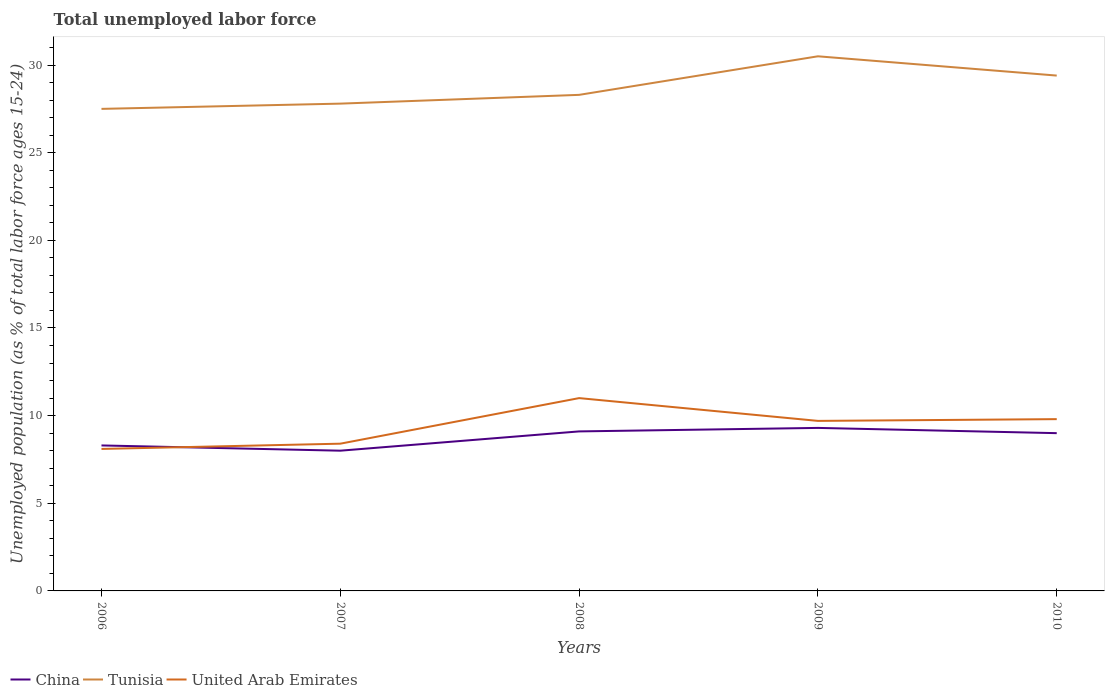Does the line corresponding to United Arab Emirates intersect with the line corresponding to Tunisia?
Make the answer very short. No. Across all years, what is the maximum percentage of unemployed population in in United Arab Emirates?
Offer a terse response. 8.1. What is the total percentage of unemployed population in in China in the graph?
Provide a succinct answer. -1. What is the difference between the highest and the second highest percentage of unemployed population in in United Arab Emirates?
Keep it short and to the point. 2.9. What is the difference between the highest and the lowest percentage of unemployed population in in China?
Your answer should be very brief. 3. How many years are there in the graph?
Offer a very short reply. 5. What is the difference between two consecutive major ticks on the Y-axis?
Give a very brief answer. 5. Are the values on the major ticks of Y-axis written in scientific E-notation?
Ensure brevity in your answer.  No. Does the graph contain any zero values?
Offer a terse response. No. Does the graph contain grids?
Make the answer very short. No. How many legend labels are there?
Give a very brief answer. 3. How are the legend labels stacked?
Give a very brief answer. Horizontal. What is the title of the graph?
Keep it short and to the point. Total unemployed labor force. Does "Swaziland" appear as one of the legend labels in the graph?
Your answer should be very brief. No. What is the label or title of the Y-axis?
Provide a short and direct response. Unemployed population (as % of total labor force ages 15-24). What is the Unemployed population (as % of total labor force ages 15-24) of China in 2006?
Ensure brevity in your answer.  8.3. What is the Unemployed population (as % of total labor force ages 15-24) in United Arab Emirates in 2006?
Provide a short and direct response. 8.1. What is the Unemployed population (as % of total labor force ages 15-24) in China in 2007?
Your response must be concise. 8. What is the Unemployed population (as % of total labor force ages 15-24) in Tunisia in 2007?
Your answer should be very brief. 27.8. What is the Unemployed population (as % of total labor force ages 15-24) in United Arab Emirates in 2007?
Your response must be concise. 8.4. What is the Unemployed population (as % of total labor force ages 15-24) in China in 2008?
Give a very brief answer. 9.1. What is the Unemployed population (as % of total labor force ages 15-24) in Tunisia in 2008?
Offer a very short reply. 28.3. What is the Unemployed population (as % of total labor force ages 15-24) in China in 2009?
Your answer should be compact. 9.3. What is the Unemployed population (as % of total labor force ages 15-24) of Tunisia in 2009?
Give a very brief answer. 30.5. What is the Unemployed population (as % of total labor force ages 15-24) of United Arab Emirates in 2009?
Offer a very short reply. 9.7. What is the Unemployed population (as % of total labor force ages 15-24) of Tunisia in 2010?
Offer a very short reply. 29.4. What is the Unemployed population (as % of total labor force ages 15-24) of United Arab Emirates in 2010?
Provide a short and direct response. 9.8. Across all years, what is the maximum Unemployed population (as % of total labor force ages 15-24) in China?
Your answer should be compact. 9.3. Across all years, what is the maximum Unemployed population (as % of total labor force ages 15-24) of Tunisia?
Provide a short and direct response. 30.5. Across all years, what is the maximum Unemployed population (as % of total labor force ages 15-24) in United Arab Emirates?
Provide a succinct answer. 11. Across all years, what is the minimum Unemployed population (as % of total labor force ages 15-24) in China?
Your answer should be very brief. 8. Across all years, what is the minimum Unemployed population (as % of total labor force ages 15-24) in Tunisia?
Offer a terse response. 27.5. Across all years, what is the minimum Unemployed population (as % of total labor force ages 15-24) of United Arab Emirates?
Offer a very short reply. 8.1. What is the total Unemployed population (as % of total labor force ages 15-24) of China in the graph?
Your answer should be compact. 43.7. What is the total Unemployed population (as % of total labor force ages 15-24) of Tunisia in the graph?
Your answer should be very brief. 143.5. What is the total Unemployed population (as % of total labor force ages 15-24) in United Arab Emirates in the graph?
Offer a very short reply. 47. What is the difference between the Unemployed population (as % of total labor force ages 15-24) of United Arab Emirates in 2006 and that in 2007?
Ensure brevity in your answer.  -0.3. What is the difference between the Unemployed population (as % of total labor force ages 15-24) of China in 2006 and that in 2008?
Make the answer very short. -0.8. What is the difference between the Unemployed population (as % of total labor force ages 15-24) in Tunisia in 2006 and that in 2008?
Give a very brief answer. -0.8. What is the difference between the Unemployed population (as % of total labor force ages 15-24) of China in 2006 and that in 2010?
Your response must be concise. -0.7. What is the difference between the Unemployed population (as % of total labor force ages 15-24) in Tunisia in 2006 and that in 2010?
Provide a short and direct response. -1.9. What is the difference between the Unemployed population (as % of total labor force ages 15-24) of Tunisia in 2007 and that in 2008?
Give a very brief answer. -0.5. What is the difference between the Unemployed population (as % of total labor force ages 15-24) in United Arab Emirates in 2007 and that in 2008?
Your answer should be very brief. -2.6. What is the difference between the Unemployed population (as % of total labor force ages 15-24) in Tunisia in 2007 and that in 2009?
Keep it short and to the point. -2.7. What is the difference between the Unemployed population (as % of total labor force ages 15-24) of China in 2007 and that in 2010?
Make the answer very short. -1. What is the difference between the Unemployed population (as % of total labor force ages 15-24) in United Arab Emirates in 2007 and that in 2010?
Give a very brief answer. -1.4. What is the difference between the Unemployed population (as % of total labor force ages 15-24) in United Arab Emirates in 2008 and that in 2009?
Your response must be concise. 1.3. What is the difference between the Unemployed population (as % of total labor force ages 15-24) of Tunisia in 2008 and that in 2010?
Offer a very short reply. -1.1. What is the difference between the Unemployed population (as % of total labor force ages 15-24) of United Arab Emirates in 2008 and that in 2010?
Your answer should be very brief. 1.2. What is the difference between the Unemployed population (as % of total labor force ages 15-24) in China in 2009 and that in 2010?
Offer a very short reply. 0.3. What is the difference between the Unemployed population (as % of total labor force ages 15-24) of Tunisia in 2009 and that in 2010?
Your answer should be compact. 1.1. What is the difference between the Unemployed population (as % of total labor force ages 15-24) in United Arab Emirates in 2009 and that in 2010?
Provide a short and direct response. -0.1. What is the difference between the Unemployed population (as % of total labor force ages 15-24) of China in 2006 and the Unemployed population (as % of total labor force ages 15-24) of Tunisia in 2007?
Give a very brief answer. -19.5. What is the difference between the Unemployed population (as % of total labor force ages 15-24) of China in 2006 and the Unemployed population (as % of total labor force ages 15-24) of United Arab Emirates in 2007?
Keep it short and to the point. -0.1. What is the difference between the Unemployed population (as % of total labor force ages 15-24) of China in 2006 and the Unemployed population (as % of total labor force ages 15-24) of Tunisia in 2008?
Your response must be concise. -20. What is the difference between the Unemployed population (as % of total labor force ages 15-24) of Tunisia in 2006 and the Unemployed population (as % of total labor force ages 15-24) of United Arab Emirates in 2008?
Your response must be concise. 16.5. What is the difference between the Unemployed population (as % of total labor force ages 15-24) in China in 2006 and the Unemployed population (as % of total labor force ages 15-24) in Tunisia in 2009?
Provide a succinct answer. -22.2. What is the difference between the Unemployed population (as % of total labor force ages 15-24) in Tunisia in 2006 and the Unemployed population (as % of total labor force ages 15-24) in United Arab Emirates in 2009?
Your answer should be compact. 17.8. What is the difference between the Unemployed population (as % of total labor force ages 15-24) of China in 2006 and the Unemployed population (as % of total labor force ages 15-24) of Tunisia in 2010?
Your response must be concise. -21.1. What is the difference between the Unemployed population (as % of total labor force ages 15-24) in China in 2006 and the Unemployed population (as % of total labor force ages 15-24) in United Arab Emirates in 2010?
Offer a very short reply. -1.5. What is the difference between the Unemployed population (as % of total labor force ages 15-24) in Tunisia in 2006 and the Unemployed population (as % of total labor force ages 15-24) in United Arab Emirates in 2010?
Provide a succinct answer. 17.7. What is the difference between the Unemployed population (as % of total labor force ages 15-24) of China in 2007 and the Unemployed population (as % of total labor force ages 15-24) of Tunisia in 2008?
Your answer should be very brief. -20.3. What is the difference between the Unemployed population (as % of total labor force ages 15-24) of China in 2007 and the Unemployed population (as % of total labor force ages 15-24) of Tunisia in 2009?
Provide a short and direct response. -22.5. What is the difference between the Unemployed population (as % of total labor force ages 15-24) of China in 2007 and the Unemployed population (as % of total labor force ages 15-24) of United Arab Emirates in 2009?
Ensure brevity in your answer.  -1.7. What is the difference between the Unemployed population (as % of total labor force ages 15-24) in China in 2007 and the Unemployed population (as % of total labor force ages 15-24) in Tunisia in 2010?
Your response must be concise. -21.4. What is the difference between the Unemployed population (as % of total labor force ages 15-24) in China in 2007 and the Unemployed population (as % of total labor force ages 15-24) in United Arab Emirates in 2010?
Provide a succinct answer. -1.8. What is the difference between the Unemployed population (as % of total labor force ages 15-24) in China in 2008 and the Unemployed population (as % of total labor force ages 15-24) in Tunisia in 2009?
Provide a succinct answer. -21.4. What is the difference between the Unemployed population (as % of total labor force ages 15-24) in China in 2008 and the Unemployed population (as % of total labor force ages 15-24) in Tunisia in 2010?
Offer a terse response. -20.3. What is the difference between the Unemployed population (as % of total labor force ages 15-24) in China in 2009 and the Unemployed population (as % of total labor force ages 15-24) in Tunisia in 2010?
Your response must be concise. -20.1. What is the difference between the Unemployed population (as % of total labor force ages 15-24) in China in 2009 and the Unemployed population (as % of total labor force ages 15-24) in United Arab Emirates in 2010?
Your response must be concise. -0.5. What is the difference between the Unemployed population (as % of total labor force ages 15-24) of Tunisia in 2009 and the Unemployed population (as % of total labor force ages 15-24) of United Arab Emirates in 2010?
Your response must be concise. 20.7. What is the average Unemployed population (as % of total labor force ages 15-24) in China per year?
Ensure brevity in your answer.  8.74. What is the average Unemployed population (as % of total labor force ages 15-24) in Tunisia per year?
Your answer should be compact. 28.7. In the year 2006, what is the difference between the Unemployed population (as % of total labor force ages 15-24) of China and Unemployed population (as % of total labor force ages 15-24) of Tunisia?
Provide a short and direct response. -19.2. In the year 2006, what is the difference between the Unemployed population (as % of total labor force ages 15-24) of Tunisia and Unemployed population (as % of total labor force ages 15-24) of United Arab Emirates?
Provide a short and direct response. 19.4. In the year 2007, what is the difference between the Unemployed population (as % of total labor force ages 15-24) in China and Unemployed population (as % of total labor force ages 15-24) in Tunisia?
Ensure brevity in your answer.  -19.8. In the year 2007, what is the difference between the Unemployed population (as % of total labor force ages 15-24) of China and Unemployed population (as % of total labor force ages 15-24) of United Arab Emirates?
Ensure brevity in your answer.  -0.4. In the year 2007, what is the difference between the Unemployed population (as % of total labor force ages 15-24) in Tunisia and Unemployed population (as % of total labor force ages 15-24) in United Arab Emirates?
Provide a short and direct response. 19.4. In the year 2008, what is the difference between the Unemployed population (as % of total labor force ages 15-24) of China and Unemployed population (as % of total labor force ages 15-24) of Tunisia?
Make the answer very short. -19.2. In the year 2009, what is the difference between the Unemployed population (as % of total labor force ages 15-24) in China and Unemployed population (as % of total labor force ages 15-24) in Tunisia?
Ensure brevity in your answer.  -21.2. In the year 2009, what is the difference between the Unemployed population (as % of total labor force ages 15-24) of China and Unemployed population (as % of total labor force ages 15-24) of United Arab Emirates?
Provide a succinct answer. -0.4. In the year 2009, what is the difference between the Unemployed population (as % of total labor force ages 15-24) in Tunisia and Unemployed population (as % of total labor force ages 15-24) in United Arab Emirates?
Keep it short and to the point. 20.8. In the year 2010, what is the difference between the Unemployed population (as % of total labor force ages 15-24) in China and Unemployed population (as % of total labor force ages 15-24) in Tunisia?
Provide a succinct answer. -20.4. In the year 2010, what is the difference between the Unemployed population (as % of total labor force ages 15-24) of China and Unemployed population (as % of total labor force ages 15-24) of United Arab Emirates?
Make the answer very short. -0.8. In the year 2010, what is the difference between the Unemployed population (as % of total labor force ages 15-24) of Tunisia and Unemployed population (as % of total labor force ages 15-24) of United Arab Emirates?
Your answer should be very brief. 19.6. What is the ratio of the Unemployed population (as % of total labor force ages 15-24) in China in 2006 to that in 2007?
Keep it short and to the point. 1.04. What is the ratio of the Unemployed population (as % of total labor force ages 15-24) of China in 2006 to that in 2008?
Offer a terse response. 0.91. What is the ratio of the Unemployed population (as % of total labor force ages 15-24) of Tunisia in 2006 to that in 2008?
Offer a terse response. 0.97. What is the ratio of the Unemployed population (as % of total labor force ages 15-24) of United Arab Emirates in 2006 to that in 2008?
Your answer should be very brief. 0.74. What is the ratio of the Unemployed population (as % of total labor force ages 15-24) in China in 2006 to that in 2009?
Give a very brief answer. 0.89. What is the ratio of the Unemployed population (as % of total labor force ages 15-24) of Tunisia in 2006 to that in 2009?
Offer a very short reply. 0.9. What is the ratio of the Unemployed population (as % of total labor force ages 15-24) in United Arab Emirates in 2006 to that in 2009?
Offer a terse response. 0.84. What is the ratio of the Unemployed population (as % of total labor force ages 15-24) in China in 2006 to that in 2010?
Offer a terse response. 0.92. What is the ratio of the Unemployed population (as % of total labor force ages 15-24) of Tunisia in 2006 to that in 2010?
Provide a succinct answer. 0.94. What is the ratio of the Unemployed population (as % of total labor force ages 15-24) in United Arab Emirates in 2006 to that in 2010?
Offer a terse response. 0.83. What is the ratio of the Unemployed population (as % of total labor force ages 15-24) of China in 2007 to that in 2008?
Your response must be concise. 0.88. What is the ratio of the Unemployed population (as % of total labor force ages 15-24) in Tunisia in 2007 to that in 2008?
Your response must be concise. 0.98. What is the ratio of the Unemployed population (as % of total labor force ages 15-24) in United Arab Emirates in 2007 to that in 2008?
Ensure brevity in your answer.  0.76. What is the ratio of the Unemployed population (as % of total labor force ages 15-24) of China in 2007 to that in 2009?
Your answer should be compact. 0.86. What is the ratio of the Unemployed population (as % of total labor force ages 15-24) of Tunisia in 2007 to that in 2009?
Give a very brief answer. 0.91. What is the ratio of the Unemployed population (as % of total labor force ages 15-24) of United Arab Emirates in 2007 to that in 2009?
Ensure brevity in your answer.  0.87. What is the ratio of the Unemployed population (as % of total labor force ages 15-24) in Tunisia in 2007 to that in 2010?
Give a very brief answer. 0.95. What is the ratio of the Unemployed population (as % of total labor force ages 15-24) of United Arab Emirates in 2007 to that in 2010?
Offer a terse response. 0.86. What is the ratio of the Unemployed population (as % of total labor force ages 15-24) of China in 2008 to that in 2009?
Provide a succinct answer. 0.98. What is the ratio of the Unemployed population (as % of total labor force ages 15-24) in Tunisia in 2008 to that in 2009?
Your answer should be very brief. 0.93. What is the ratio of the Unemployed population (as % of total labor force ages 15-24) in United Arab Emirates in 2008 to that in 2009?
Provide a succinct answer. 1.13. What is the ratio of the Unemployed population (as % of total labor force ages 15-24) in China in 2008 to that in 2010?
Provide a short and direct response. 1.01. What is the ratio of the Unemployed population (as % of total labor force ages 15-24) in Tunisia in 2008 to that in 2010?
Offer a very short reply. 0.96. What is the ratio of the Unemployed population (as % of total labor force ages 15-24) of United Arab Emirates in 2008 to that in 2010?
Keep it short and to the point. 1.12. What is the ratio of the Unemployed population (as % of total labor force ages 15-24) of Tunisia in 2009 to that in 2010?
Provide a short and direct response. 1.04. What is the difference between the highest and the second highest Unemployed population (as % of total labor force ages 15-24) of Tunisia?
Give a very brief answer. 1.1. What is the difference between the highest and the second highest Unemployed population (as % of total labor force ages 15-24) of United Arab Emirates?
Keep it short and to the point. 1.2. What is the difference between the highest and the lowest Unemployed population (as % of total labor force ages 15-24) of Tunisia?
Your answer should be compact. 3. What is the difference between the highest and the lowest Unemployed population (as % of total labor force ages 15-24) in United Arab Emirates?
Make the answer very short. 2.9. 